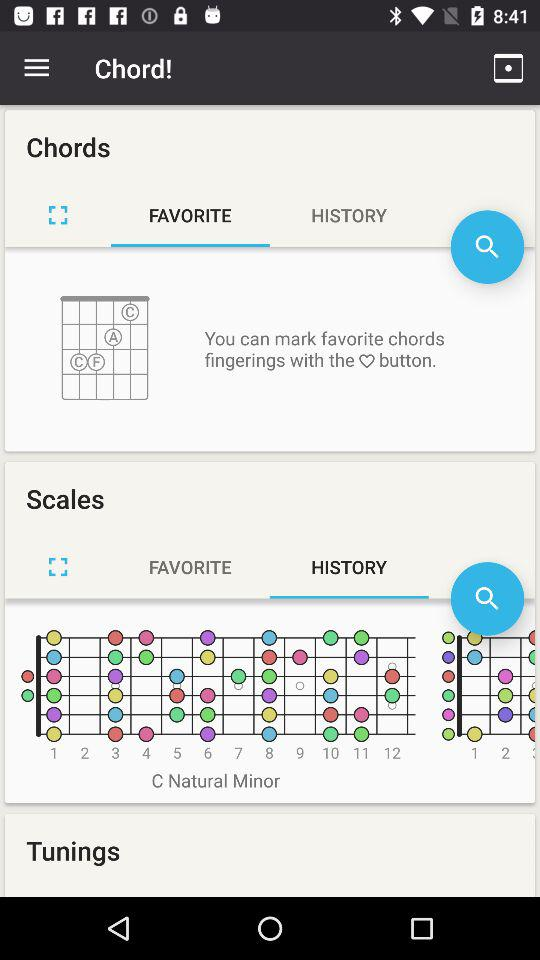Which tab is selected? The selected tab is "FAVORITE". 